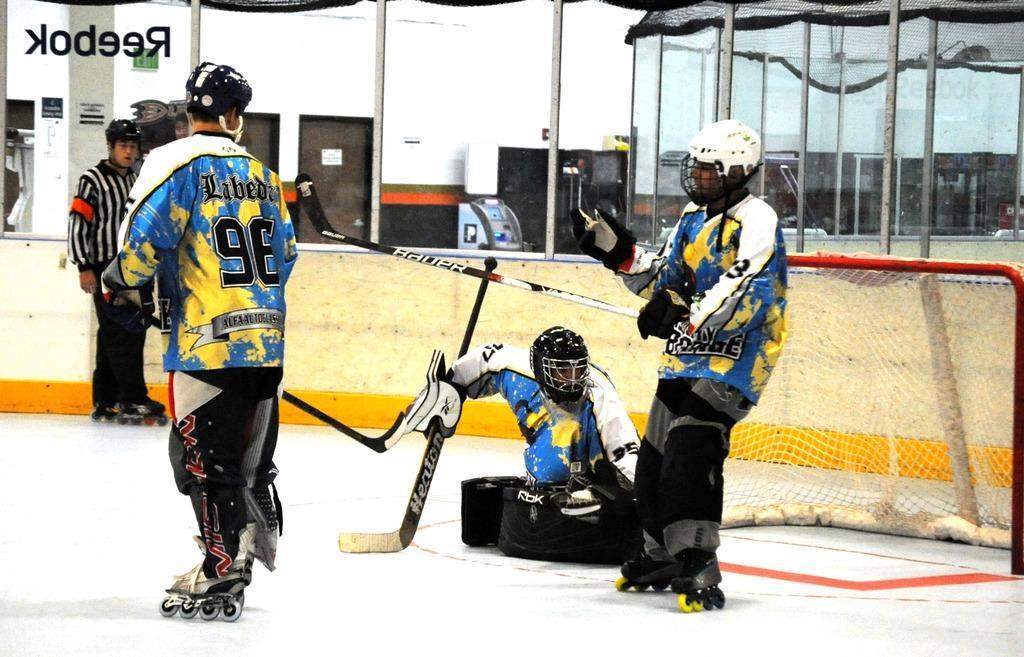What are the people in the image wearing on their heads? The people in the image are wearing helmets. What are the people holding in their hands? The people are holding sticks. What is present in the image that is used for separating the playing area? There is a net in the image. What is the background of the image made up of? There is a wall in the image. Can you see any steam coming from the rake in the image? There is no rake or steam present in the image. 